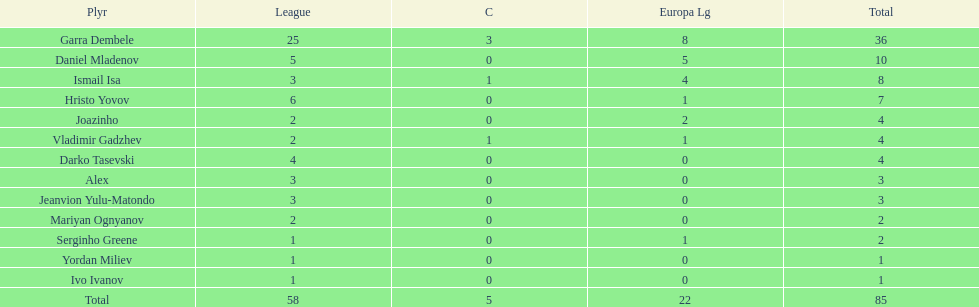What is the difference between vladimir gadzhev and yordan miliev's scores? 3. 